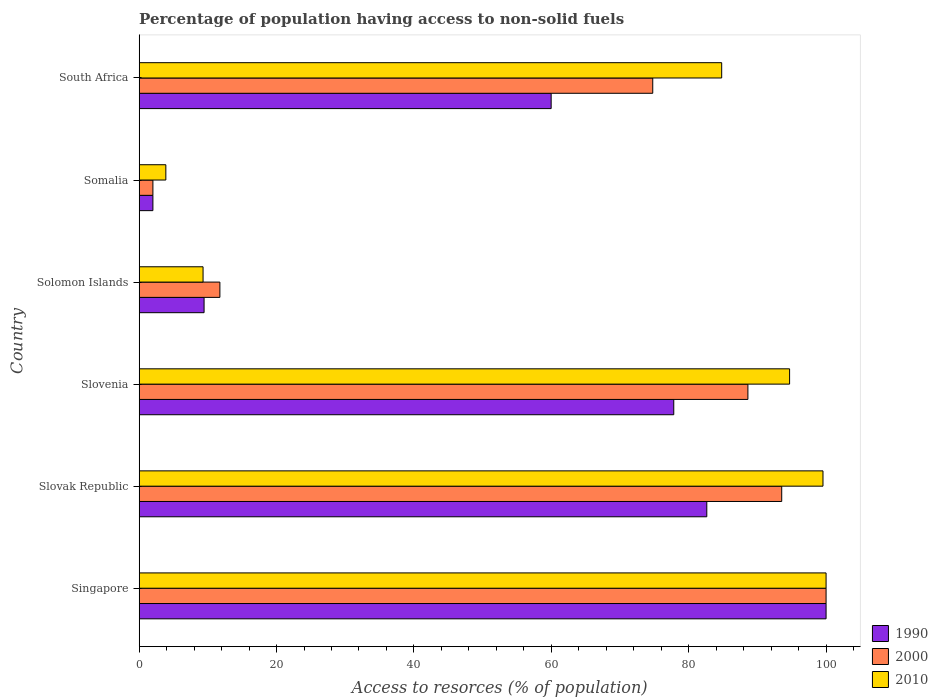How many bars are there on the 3rd tick from the bottom?
Provide a succinct answer. 3. What is the label of the 2nd group of bars from the top?
Provide a short and direct response. Somalia. In how many cases, is the number of bars for a given country not equal to the number of legend labels?
Your answer should be very brief. 0. Across all countries, what is the maximum percentage of population having access to non-solid fuels in 2000?
Ensure brevity in your answer.  100. Across all countries, what is the minimum percentage of population having access to non-solid fuels in 2000?
Give a very brief answer. 2. In which country was the percentage of population having access to non-solid fuels in 2010 maximum?
Keep it short and to the point. Singapore. In which country was the percentage of population having access to non-solid fuels in 2010 minimum?
Make the answer very short. Somalia. What is the total percentage of population having access to non-solid fuels in 2000 in the graph?
Provide a short and direct response. 370.68. What is the difference between the percentage of population having access to non-solid fuels in 2010 in Slovak Republic and that in Slovenia?
Offer a very short reply. 4.86. What is the difference between the percentage of population having access to non-solid fuels in 2010 in Slovak Republic and the percentage of population having access to non-solid fuels in 2000 in Solomon Islands?
Keep it short and to the point. 87.8. What is the average percentage of population having access to non-solid fuels in 1990 per country?
Offer a terse response. 55.31. What is the difference between the percentage of population having access to non-solid fuels in 2010 and percentage of population having access to non-solid fuels in 2000 in Solomon Islands?
Make the answer very short. -2.45. In how many countries, is the percentage of population having access to non-solid fuels in 2010 greater than 16 %?
Provide a succinct answer. 4. What is the ratio of the percentage of population having access to non-solid fuels in 2000 in Singapore to that in Somalia?
Provide a succinct answer. 50. Is the percentage of population having access to non-solid fuels in 2000 in Singapore less than that in Solomon Islands?
Make the answer very short. No. Is the difference between the percentage of population having access to non-solid fuels in 2010 in Solomon Islands and South Africa greater than the difference between the percentage of population having access to non-solid fuels in 2000 in Solomon Islands and South Africa?
Offer a terse response. No. What is the difference between the highest and the second highest percentage of population having access to non-solid fuels in 1990?
Keep it short and to the point. 17.37. What is the difference between the highest and the lowest percentage of population having access to non-solid fuels in 1990?
Give a very brief answer. 98. What does the 3rd bar from the bottom in Solomon Islands represents?
Your answer should be compact. 2010. Is it the case that in every country, the sum of the percentage of population having access to non-solid fuels in 2010 and percentage of population having access to non-solid fuels in 1990 is greater than the percentage of population having access to non-solid fuels in 2000?
Your answer should be compact. Yes. Are all the bars in the graph horizontal?
Make the answer very short. Yes. Does the graph contain grids?
Make the answer very short. No. Where does the legend appear in the graph?
Offer a very short reply. Bottom right. How many legend labels are there?
Your response must be concise. 3. What is the title of the graph?
Offer a terse response. Percentage of population having access to non-solid fuels. What is the label or title of the X-axis?
Offer a very short reply. Access to resorces (% of population). What is the Access to resorces (% of population) of 2000 in Singapore?
Offer a terse response. 100. What is the Access to resorces (% of population) in 1990 in Slovak Republic?
Provide a short and direct response. 82.63. What is the Access to resorces (% of population) in 2000 in Slovak Republic?
Provide a short and direct response. 93.54. What is the Access to resorces (% of population) of 2010 in Slovak Republic?
Your response must be concise. 99.55. What is the Access to resorces (% of population) of 1990 in Slovenia?
Keep it short and to the point. 77.82. What is the Access to resorces (% of population) in 2000 in Slovenia?
Offer a very short reply. 88.62. What is the Access to resorces (% of population) in 2010 in Slovenia?
Keep it short and to the point. 94.69. What is the Access to resorces (% of population) in 1990 in Solomon Islands?
Offer a very short reply. 9.45. What is the Access to resorces (% of population) of 2000 in Solomon Islands?
Your answer should be very brief. 11.75. What is the Access to resorces (% of population) in 2010 in Solomon Islands?
Offer a terse response. 9.3. What is the Access to resorces (% of population) in 1990 in Somalia?
Your answer should be compact. 2. What is the Access to resorces (% of population) in 2000 in Somalia?
Make the answer very short. 2. What is the Access to resorces (% of population) of 2010 in Somalia?
Provide a short and direct response. 3.89. What is the Access to resorces (% of population) in 1990 in South Africa?
Provide a short and direct response. 59.98. What is the Access to resorces (% of population) of 2000 in South Africa?
Your response must be concise. 74.77. What is the Access to resorces (% of population) of 2010 in South Africa?
Make the answer very short. 84.8. Across all countries, what is the maximum Access to resorces (% of population) in 1990?
Offer a terse response. 100. Across all countries, what is the minimum Access to resorces (% of population) of 1990?
Keep it short and to the point. 2. Across all countries, what is the minimum Access to resorces (% of population) of 2000?
Your response must be concise. 2. Across all countries, what is the minimum Access to resorces (% of population) of 2010?
Give a very brief answer. 3.89. What is the total Access to resorces (% of population) of 1990 in the graph?
Your response must be concise. 331.89. What is the total Access to resorces (% of population) in 2000 in the graph?
Ensure brevity in your answer.  370.68. What is the total Access to resorces (% of population) in 2010 in the graph?
Offer a very short reply. 392.23. What is the difference between the Access to resorces (% of population) of 1990 in Singapore and that in Slovak Republic?
Your answer should be compact. 17.37. What is the difference between the Access to resorces (% of population) of 2000 in Singapore and that in Slovak Republic?
Your answer should be very brief. 6.46. What is the difference between the Access to resorces (% of population) in 2010 in Singapore and that in Slovak Republic?
Give a very brief answer. 0.45. What is the difference between the Access to resorces (% of population) of 1990 in Singapore and that in Slovenia?
Ensure brevity in your answer.  22.18. What is the difference between the Access to resorces (% of population) in 2000 in Singapore and that in Slovenia?
Offer a terse response. 11.38. What is the difference between the Access to resorces (% of population) of 2010 in Singapore and that in Slovenia?
Ensure brevity in your answer.  5.31. What is the difference between the Access to resorces (% of population) of 1990 in Singapore and that in Solomon Islands?
Your answer should be compact. 90.55. What is the difference between the Access to resorces (% of population) of 2000 in Singapore and that in Solomon Islands?
Provide a succinct answer. 88.25. What is the difference between the Access to resorces (% of population) of 2010 in Singapore and that in Solomon Islands?
Offer a very short reply. 90.7. What is the difference between the Access to resorces (% of population) in 2000 in Singapore and that in Somalia?
Your response must be concise. 98. What is the difference between the Access to resorces (% of population) of 2010 in Singapore and that in Somalia?
Give a very brief answer. 96.11. What is the difference between the Access to resorces (% of population) of 1990 in Singapore and that in South Africa?
Provide a succinct answer. 40.02. What is the difference between the Access to resorces (% of population) in 2000 in Singapore and that in South Africa?
Offer a terse response. 25.23. What is the difference between the Access to resorces (% of population) in 2010 in Singapore and that in South Africa?
Provide a short and direct response. 15.2. What is the difference between the Access to resorces (% of population) in 1990 in Slovak Republic and that in Slovenia?
Your answer should be very brief. 4.81. What is the difference between the Access to resorces (% of population) of 2000 in Slovak Republic and that in Slovenia?
Make the answer very short. 4.92. What is the difference between the Access to resorces (% of population) in 2010 in Slovak Republic and that in Slovenia?
Your response must be concise. 4.86. What is the difference between the Access to resorces (% of population) in 1990 in Slovak Republic and that in Solomon Islands?
Your answer should be very brief. 73.18. What is the difference between the Access to resorces (% of population) of 2000 in Slovak Republic and that in Solomon Islands?
Your answer should be very brief. 81.79. What is the difference between the Access to resorces (% of population) in 2010 in Slovak Republic and that in Solomon Islands?
Give a very brief answer. 90.25. What is the difference between the Access to resorces (% of population) in 1990 in Slovak Republic and that in Somalia?
Provide a succinct answer. 80.63. What is the difference between the Access to resorces (% of population) in 2000 in Slovak Republic and that in Somalia?
Your response must be concise. 91.54. What is the difference between the Access to resorces (% of population) of 2010 in Slovak Republic and that in Somalia?
Make the answer very short. 95.66. What is the difference between the Access to resorces (% of population) in 1990 in Slovak Republic and that in South Africa?
Provide a short and direct response. 22.66. What is the difference between the Access to resorces (% of population) in 2000 in Slovak Republic and that in South Africa?
Provide a succinct answer. 18.78. What is the difference between the Access to resorces (% of population) of 2010 in Slovak Republic and that in South Africa?
Provide a short and direct response. 14.75. What is the difference between the Access to resorces (% of population) in 1990 in Slovenia and that in Solomon Islands?
Offer a terse response. 68.37. What is the difference between the Access to resorces (% of population) in 2000 in Slovenia and that in Solomon Islands?
Your response must be concise. 76.87. What is the difference between the Access to resorces (% of population) of 2010 in Slovenia and that in Solomon Islands?
Your response must be concise. 85.39. What is the difference between the Access to resorces (% of population) in 1990 in Slovenia and that in Somalia?
Provide a succinct answer. 75.83. What is the difference between the Access to resorces (% of population) in 2000 in Slovenia and that in Somalia?
Your response must be concise. 86.62. What is the difference between the Access to resorces (% of population) of 2010 in Slovenia and that in Somalia?
Provide a short and direct response. 90.8. What is the difference between the Access to resorces (% of population) of 1990 in Slovenia and that in South Africa?
Your answer should be very brief. 17.85. What is the difference between the Access to resorces (% of population) in 2000 in Slovenia and that in South Africa?
Provide a short and direct response. 13.85. What is the difference between the Access to resorces (% of population) of 2010 in Slovenia and that in South Africa?
Make the answer very short. 9.89. What is the difference between the Access to resorces (% of population) in 1990 in Solomon Islands and that in Somalia?
Ensure brevity in your answer.  7.45. What is the difference between the Access to resorces (% of population) of 2000 in Solomon Islands and that in Somalia?
Offer a terse response. 9.75. What is the difference between the Access to resorces (% of population) in 2010 in Solomon Islands and that in Somalia?
Offer a very short reply. 5.42. What is the difference between the Access to resorces (% of population) of 1990 in Solomon Islands and that in South Africa?
Your answer should be very brief. -50.53. What is the difference between the Access to resorces (% of population) of 2000 in Solomon Islands and that in South Africa?
Make the answer very short. -63.02. What is the difference between the Access to resorces (% of population) of 2010 in Solomon Islands and that in South Africa?
Provide a succinct answer. -75.5. What is the difference between the Access to resorces (% of population) in 1990 in Somalia and that in South Africa?
Offer a terse response. -57.98. What is the difference between the Access to resorces (% of population) in 2000 in Somalia and that in South Africa?
Your answer should be compact. -72.77. What is the difference between the Access to resorces (% of population) in 2010 in Somalia and that in South Africa?
Ensure brevity in your answer.  -80.92. What is the difference between the Access to resorces (% of population) of 1990 in Singapore and the Access to resorces (% of population) of 2000 in Slovak Republic?
Offer a very short reply. 6.46. What is the difference between the Access to resorces (% of population) in 1990 in Singapore and the Access to resorces (% of population) in 2010 in Slovak Republic?
Your response must be concise. 0.45. What is the difference between the Access to resorces (% of population) in 2000 in Singapore and the Access to resorces (% of population) in 2010 in Slovak Republic?
Your answer should be very brief. 0.45. What is the difference between the Access to resorces (% of population) in 1990 in Singapore and the Access to resorces (% of population) in 2000 in Slovenia?
Your answer should be very brief. 11.38. What is the difference between the Access to resorces (% of population) of 1990 in Singapore and the Access to resorces (% of population) of 2010 in Slovenia?
Your answer should be very brief. 5.31. What is the difference between the Access to resorces (% of population) of 2000 in Singapore and the Access to resorces (% of population) of 2010 in Slovenia?
Give a very brief answer. 5.31. What is the difference between the Access to resorces (% of population) in 1990 in Singapore and the Access to resorces (% of population) in 2000 in Solomon Islands?
Give a very brief answer. 88.25. What is the difference between the Access to resorces (% of population) in 1990 in Singapore and the Access to resorces (% of population) in 2010 in Solomon Islands?
Make the answer very short. 90.7. What is the difference between the Access to resorces (% of population) of 2000 in Singapore and the Access to resorces (% of population) of 2010 in Solomon Islands?
Offer a terse response. 90.7. What is the difference between the Access to resorces (% of population) in 1990 in Singapore and the Access to resorces (% of population) in 2010 in Somalia?
Your response must be concise. 96.11. What is the difference between the Access to resorces (% of population) in 2000 in Singapore and the Access to resorces (% of population) in 2010 in Somalia?
Give a very brief answer. 96.11. What is the difference between the Access to resorces (% of population) in 1990 in Singapore and the Access to resorces (% of population) in 2000 in South Africa?
Give a very brief answer. 25.23. What is the difference between the Access to resorces (% of population) in 1990 in Singapore and the Access to resorces (% of population) in 2010 in South Africa?
Offer a terse response. 15.2. What is the difference between the Access to resorces (% of population) in 2000 in Singapore and the Access to resorces (% of population) in 2010 in South Africa?
Provide a short and direct response. 15.2. What is the difference between the Access to resorces (% of population) in 1990 in Slovak Republic and the Access to resorces (% of population) in 2000 in Slovenia?
Your answer should be compact. -5.99. What is the difference between the Access to resorces (% of population) in 1990 in Slovak Republic and the Access to resorces (% of population) in 2010 in Slovenia?
Make the answer very short. -12.05. What is the difference between the Access to resorces (% of population) in 2000 in Slovak Republic and the Access to resorces (% of population) in 2010 in Slovenia?
Your answer should be very brief. -1.15. What is the difference between the Access to resorces (% of population) of 1990 in Slovak Republic and the Access to resorces (% of population) of 2000 in Solomon Islands?
Your answer should be very brief. 70.88. What is the difference between the Access to resorces (% of population) in 1990 in Slovak Republic and the Access to resorces (% of population) in 2010 in Solomon Islands?
Ensure brevity in your answer.  73.33. What is the difference between the Access to resorces (% of population) in 2000 in Slovak Republic and the Access to resorces (% of population) in 2010 in Solomon Islands?
Your response must be concise. 84.24. What is the difference between the Access to resorces (% of population) of 1990 in Slovak Republic and the Access to resorces (% of population) of 2000 in Somalia?
Provide a succinct answer. 80.63. What is the difference between the Access to resorces (% of population) of 1990 in Slovak Republic and the Access to resorces (% of population) of 2010 in Somalia?
Provide a short and direct response. 78.75. What is the difference between the Access to resorces (% of population) of 2000 in Slovak Republic and the Access to resorces (% of population) of 2010 in Somalia?
Your answer should be compact. 89.66. What is the difference between the Access to resorces (% of population) of 1990 in Slovak Republic and the Access to resorces (% of population) of 2000 in South Africa?
Keep it short and to the point. 7.87. What is the difference between the Access to resorces (% of population) in 1990 in Slovak Republic and the Access to resorces (% of population) in 2010 in South Africa?
Make the answer very short. -2.17. What is the difference between the Access to resorces (% of population) of 2000 in Slovak Republic and the Access to resorces (% of population) of 2010 in South Africa?
Offer a very short reply. 8.74. What is the difference between the Access to resorces (% of population) in 1990 in Slovenia and the Access to resorces (% of population) in 2000 in Solomon Islands?
Offer a terse response. 66.07. What is the difference between the Access to resorces (% of population) in 1990 in Slovenia and the Access to resorces (% of population) in 2010 in Solomon Islands?
Your answer should be compact. 68.52. What is the difference between the Access to resorces (% of population) in 2000 in Slovenia and the Access to resorces (% of population) in 2010 in Solomon Islands?
Your response must be concise. 79.32. What is the difference between the Access to resorces (% of population) in 1990 in Slovenia and the Access to resorces (% of population) in 2000 in Somalia?
Offer a terse response. 75.83. What is the difference between the Access to resorces (% of population) in 1990 in Slovenia and the Access to resorces (% of population) in 2010 in Somalia?
Give a very brief answer. 73.94. What is the difference between the Access to resorces (% of population) of 2000 in Slovenia and the Access to resorces (% of population) of 2010 in Somalia?
Your answer should be compact. 84.73. What is the difference between the Access to resorces (% of population) of 1990 in Slovenia and the Access to resorces (% of population) of 2000 in South Africa?
Provide a short and direct response. 3.06. What is the difference between the Access to resorces (% of population) of 1990 in Slovenia and the Access to resorces (% of population) of 2010 in South Africa?
Offer a terse response. -6.98. What is the difference between the Access to resorces (% of population) of 2000 in Slovenia and the Access to resorces (% of population) of 2010 in South Africa?
Your answer should be very brief. 3.82. What is the difference between the Access to resorces (% of population) in 1990 in Solomon Islands and the Access to resorces (% of population) in 2000 in Somalia?
Ensure brevity in your answer.  7.45. What is the difference between the Access to resorces (% of population) in 1990 in Solomon Islands and the Access to resorces (% of population) in 2010 in Somalia?
Provide a short and direct response. 5.56. What is the difference between the Access to resorces (% of population) in 2000 in Solomon Islands and the Access to resorces (% of population) in 2010 in Somalia?
Provide a short and direct response. 7.87. What is the difference between the Access to resorces (% of population) of 1990 in Solomon Islands and the Access to resorces (% of population) of 2000 in South Africa?
Keep it short and to the point. -65.32. What is the difference between the Access to resorces (% of population) of 1990 in Solomon Islands and the Access to resorces (% of population) of 2010 in South Africa?
Your answer should be very brief. -75.35. What is the difference between the Access to resorces (% of population) in 2000 in Solomon Islands and the Access to resorces (% of population) in 2010 in South Africa?
Your answer should be very brief. -73.05. What is the difference between the Access to resorces (% of population) of 1990 in Somalia and the Access to resorces (% of population) of 2000 in South Africa?
Ensure brevity in your answer.  -72.77. What is the difference between the Access to resorces (% of population) in 1990 in Somalia and the Access to resorces (% of population) in 2010 in South Africa?
Provide a succinct answer. -82.8. What is the difference between the Access to resorces (% of population) of 2000 in Somalia and the Access to resorces (% of population) of 2010 in South Africa?
Provide a short and direct response. -82.8. What is the average Access to resorces (% of population) in 1990 per country?
Provide a short and direct response. 55.31. What is the average Access to resorces (% of population) of 2000 per country?
Your answer should be compact. 61.78. What is the average Access to resorces (% of population) in 2010 per country?
Provide a short and direct response. 65.37. What is the difference between the Access to resorces (% of population) of 1990 and Access to resorces (% of population) of 2000 in Slovak Republic?
Your answer should be compact. -10.91. What is the difference between the Access to resorces (% of population) of 1990 and Access to resorces (% of population) of 2010 in Slovak Republic?
Give a very brief answer. -16.91. What is the difference between the Access to resorces (% of population) in 2000 and Access to resorces (% of population) in 2010 in Slovak Republic?
Give a very brief answer. -6.01. What is the difference between the Access to resorces (% of population) of 1990 and Access to resorces (% of population) of 2000 in Slovenia?
Keep it short and to the point. -10.79. What is the difference between the Access to resorces (% of population) in 1990 and Access to resorces (% of population) in 2010 in Slovenia?
Offer a terse response. -16.86. What is the difference between the Access to resorces (% of population) of 2000 and Access to resorces (% of population) of 2010 in Slovenia?
Provide a short and direct response. -6.07. What is the difference between the Access to resorces (% of population) of 1990 and Access to resorces (% of population) of 2000 in Solomon Islands?
Offer a very short reply. -2.3. What is the difference between the Access to resorces (% of population) in 1990 and Access to resorces (% of population) in 2010 in Solomon Islands?
Your answer should be very brief. 0.15. What is the difference between the Access to resorces (% of population) of 2000 and Access to resorces (% of population) of 2010 in Solomon Islands?
Keep it short and to the point. 2.45. What is the difference between the Access to resorces (% of population) of 1990 and Access to resorces (% of population) of 2010 in Somalia?
Your answer should be very brief. -1.89. What is the difference between the Access to resorces (% of population) of 2000 and Access to resorces (% of population) of 2010 in Somalia?
Provide a succinct answer. -1.89. What is the difference between the Access to resorces (% of population) of 1990 and Access to resorces (% of population) of 2000 in South Africa?
Provide a short and direct response. -14.79. What is the difference between the Access to resorces (% of population) in 1990 and Access to resorces (% of population) in 2010 in South Africa?
Your answer should be very brief. -24.82. What is the difference between the Access to resorces (% of population) in 2000 and Access to resorces (% of population) in 2010 in South Africa?
Offer a very short reply. -10.04. What is the ratio of the Access to resorces (% of population) in 1990 in Singapore to that in Slovak Republic?
Offer a very short reply. 1.21. What is the ratio of the Access to resorces (% of population) of 2000 in Singapore to that in Slovak Republic?
Provide a succinct answer. 1.07. What is the ratio of the Access to resorces (% of population) in 1990 in Singapore to that in Slovenia?
Offer a terse response. 1.28. What is the ratio of the Access to resorces (% of population) in 2000 in Singapore to that in Slovenia?
Your response must be concise. 1.13. What is the ratio of the Access to resorces (% of population) in 2010 in Singapore to that in Slovenia?
Ensure brevity in your answer.  1.06. What is the ratio of the Access to resorces (% of population) of 1990 in Singapore to that in Solomon Islands?
Ensure brevity in your answer.  10.58. What is the ratio of the Access to resorces (% of population) in 2000 in Singapore to that in Solomon Islands?
Ensure brevity in your answer.  8.51. What is the ratio of the Access to resorces (% of population) of 2010 in Singapore to that in Solomon Islands?
Provide a succinct answer. 10.75. What is the ratio of the Access to resorces (% of population) of 2000 in Singapore to that in Somalia?
Offer a very short reply. 50. What is the ratio of the Access to resorces (% of population) in 2010 in Singapore to that in Somalia?
Offer a terse response. 25.74. What is the ratio of the Access to resorces (% of population) in 1990 in Singapore to that in South Africa?
Your response must be concise. 1.67. What is the ratio of the Access to resorces (% of population) of 2000 in Singapore to that in South Africa?
Offer a terse response. 1.34. What is the ratio of the Access to resorces (% of population) in 2010 in Singapore to that in South Africa?
Offer a very short reply. 1.18. What is the ratio of the Access to resorces (% of population) of 1990 in Slovak Republic to that in Slovenia?
Ensure brevity in your answer.  1.06. What is the ratio of the Access to resorces (% of population) in 2000 in Slovak Republic to that in Slovenia?
Give a very brief answer. 1.06. What is the ratio of the Access to resorces (% of population) in 2010 in Slovak Republic to that in Slovenia?
Your answer should be very brief. 1.05. What is the ratio of the Access to resorces (% of population) of 1990 in Slovak Republic to that in Solomon Islands?
Your answer should be very brief. 8.74. What is the ratio of the Access to resorces (% of population) of 2000 in Slovak Republic to that in Solomon Islands?
Your answer should be very brief. 7.96. What is the ratio of the Access to resorces (% of population) of 2010 in Slovak Republic to that in Solomon Islands?
Your answer should be very brief. 10.7. What is the ratio of the Access to resorces (% of population) of 1990 in Slovak Republic to that in Somalia?
Your response must be concise. 41.32. What is the ratio of the Access to resorces (% of population) in 2000 in Slovak Republic to that in Somalia?
Keep it short and to the point. 46.77. What is the ratio of the Access to resorces (% of population) of 2010 in Slovak Republic to that in Somalia?
Your answer should be very brief. 25.62. What is the ratio of the Access to resorces (% of population) in 1990 in Slovak Republic to that in South Africa?
Provide a succinct answer. 1.38. What is the ratio of the Access to resorces (% of population) in 2000 in Slovak Republic to that in South Africa?
Your answer should be very brief. 1.25. What is the ratio of the Access to resorces (% of population) in 2010 in Slovak Republic to that in South Africa?
Keep it short and to the point. 1.17. What is the ratio of the Access to resorces (% of population) in 1990 in Slovenia to that in Solomon Islands?
Your response must be concise. 8.24. What is the ratio of the Access to resorces (% of population) in 2000 in Slovenia to that in Solomon Islands?
Give a very brief answer. 7.54. What is the ratio of the Access to resorces (% of population) in 2010 in Slovenia to that in Solomon Islands?
Your answer should be very brief. 10.18. What is the ratio of the Access to resorces (% of population) in 1990 in Slovenia to that in Somalia?
Make the answer very short. 38.91. What is the ratio of the Access to resorces (% of population) in 2000 in Slovenia to that in Somalia?
Your response must be concise. 44.31. What is the ratio of the Access to resorces (% of population) in 2010 in Slovenia to that in Somalia?
Your response must be concise. 24.37. What is the ratio of the Access to resorces (% of population) in 1990 in Slovenia to that in South Africa?
Provide a succinct answer. 1.3. What is the ratio of the Access to resorces (% of population) of 2000 in Slovenia to that in South Africa?
Offer a terse response. 1.19. What is the ratio of the Access to resorces (% of population) in 2010 in Slovenia to that in South Africa?
Make the answer very short. 1.12. What is the ratio of the Access to resorces (% of population) in 1990 in Solomon Islands to that in Somalia?
Your response must be concise. 4.73. What is the ratio of the Access to resorces (% of population) of 2000 in Solomon Islands to that in Somalia?
Keep it short and to the point. 5.88. What is the ratio of the Access to resorces (% of population) of 2010 in Solomon Islands to that in Somalia?
Offer a very short reply. 2.39. What is the ratio of the Access to resorces (% of population) in 1990 in Solomon Islands to that in South Africa?
Ensure brevity in your answer.  0.16. What is the ratio of the Access to resorces (% of population) of 2000 in Solomon Islands to that in South Africa?
Provide a short and direct response. 0.16. What is the ratio of the Access to resorces (% of population) of 2010 in Solomon Islands to that in South Africa?
Offer a terse response. 0.11. What is the ratio of the Access to resorces (% of population) of 2000 in Somalia to that in South Africa?
Your answer should be very brief. 0.03. What is the ratio of the Access to resorces (% of population) in 2010 in Somalia to that in South Africa?
Your answer should be very brief. 0.05. What is the difference between the highest and the second highest Access to resorces (% of population) of 1990?
Your answer should be compact. 17.37. What is the difference between the highest and the second highest Access to resorces (% of population) in 2000?
Your answer should be very brief. 6.46. What is the difference between the highest and the second highest Access to resorces (% of population) in 2010?
Keep it short and to the point. 0.45. What is the difference between the highest and the lowest Access to resorces (% of population) of 1990?
Offer a terse response. 98. What is the difference between the highest and the lowest Access to resorces (% of population) in 2010?
Your answer should be compact. 96.11. 